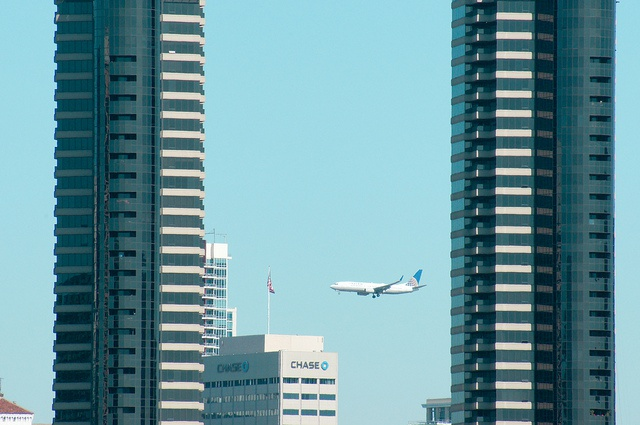Describe the objects in this image and their specific colors. I can see a airplane in lightblue, white, gray, and darkgray tones in this image. 